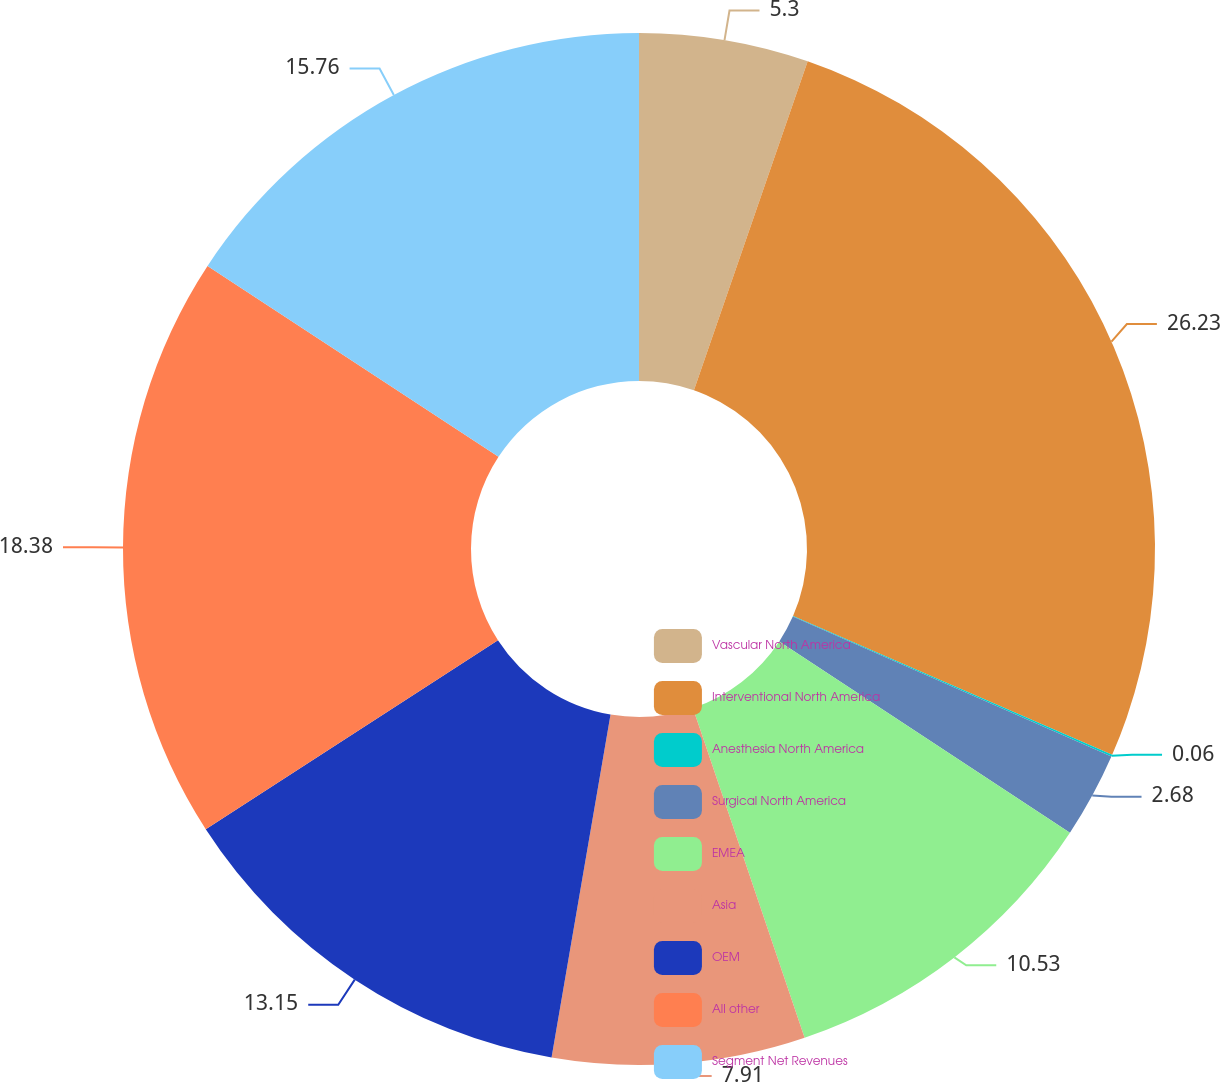<chart> <loc_0><loc_0><loc_500><loc_500><pie_chart><fcel>Vascular North America<fcel>Interventional North America<fcel>Anesthesia North America<fcel>Surgical North America<fcel>EMEA<fcel>Asia<fcel>OEM<fcel>All other<fcel>Segment Net Revenues<nl><fcel>5.3%<fcel>26.23%<fcel>0.06%<fcel>2.68%<fcel>10.53%<fcel>7.91%<fcel>13.15%<fcel>18.38%<fcel>15.76%<nl></chart> 